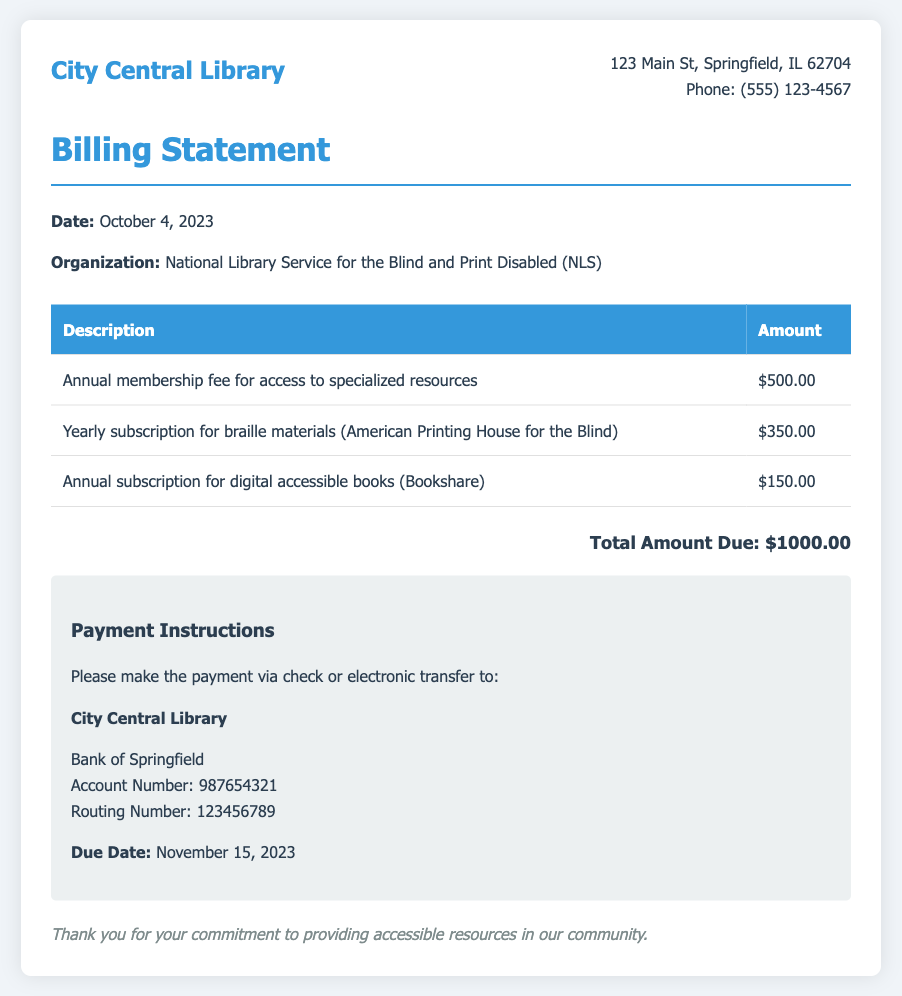what is the date of the billing statement? The date of the billing statement is specified in the details section as October 4, 2023.
Answer: October 4, 2023 who is the organization listed in the billing statement? The organization mentioned in the document is the National Library Service for the Blind and Print Disabled (NLS).
Answer: National Library Service for the Blind and Print Disabled (NLS) what is the total amount due? The total amount due is provided in the total section of the document as $1000.00.
Answer: $1000.00 how much is the annual membership fee? The annual membership fee for access to specialized resources is listed as $500.00.
Answer: $500.00 what is the due date for payment? The due date for payment is mentioned as November 15, 2023.
Answer: November 15, 2023 what is included in the yearly subscription for braille materials? The yearly subscription for braille materials is for resources from the American Printing House for the Blind.
Answer: American Printing House for the Blind which bank should the payment be made to? The payment should be made to the Bank of Springfield as specified in the payment instructions.
Answer: Bank of Springfield how much does the subscription for digital accessible books cost? The cost of the annual subscription for digital accessible books is $150.00 as per the billing statement.
Answer: $150.00 